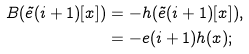<formula> <loc_0><loc_0><loc_500><loc_500>B ( \tilde { e } ( i + 1 ) [ x ] ) & = - h ( \tilde { e } ( i + 1 ) [ x ] ) , \\ & = - e ( i + 1 ) h ( x ) ; \\</formula> 